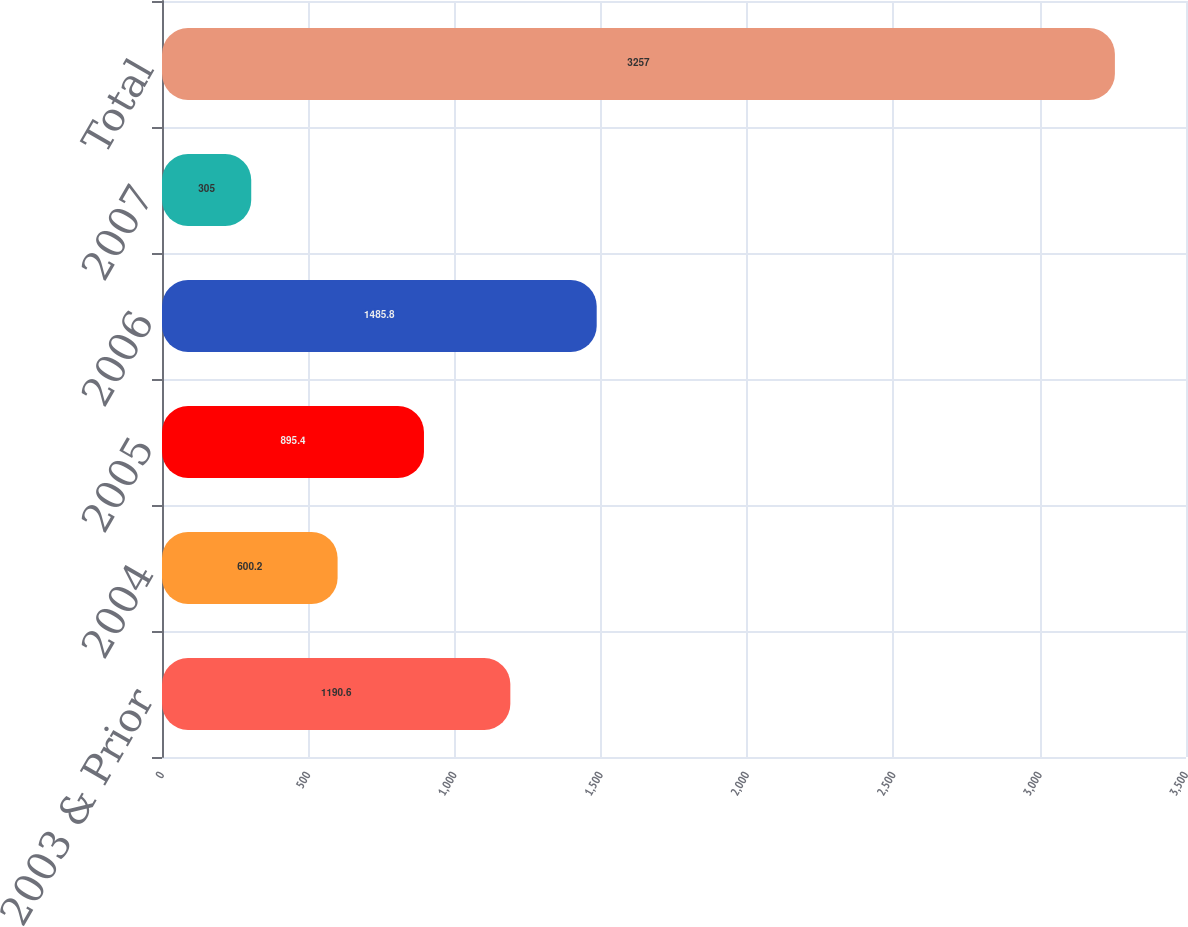<chart> <loc_0><loc_0><loc_500><loc_500><bar_chart><fcel>2003 & Prior<fcel>2004<fcel>2005<fcel>2006<fcel>2007<fcel>Total<nl><fcel>1190.6<fcel>600.2<fcel>895.4<fcel>1485.8<fcel>305<fcel>3257<nl></chart> 